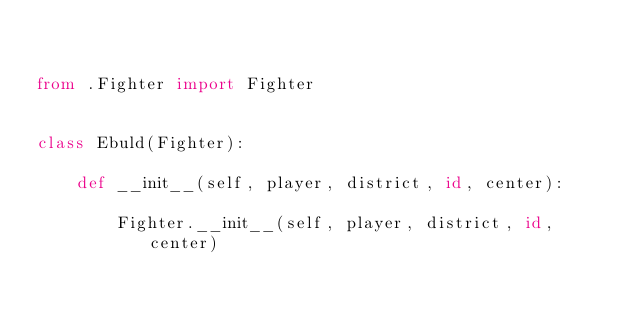Convert code to text. <code><loc_0><loc_0><loc_500><loc_500><_Python_>

from .Fighter import Fighter


class Ebuld(Fighter):

    def __init__(self, player, district, id, center):

        Fighter.__init__(self, player, district, id, center)

</code> 